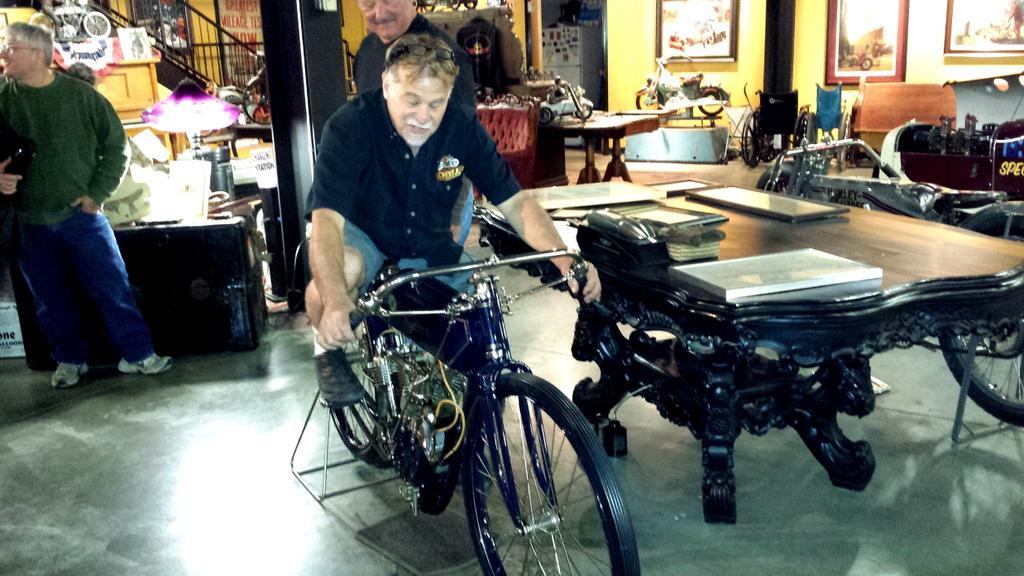Could you give a brief overview of what you see in this image? In this picture, there is a man at the center riding bicycle which is on its stand. Behind him there is a man who is watching him. At the left, there is a person who is seeing someone else. It seems like a house, here there are tables and photo frames on it. This is a yellow wall on which photo frames are present. Here there are steps. 